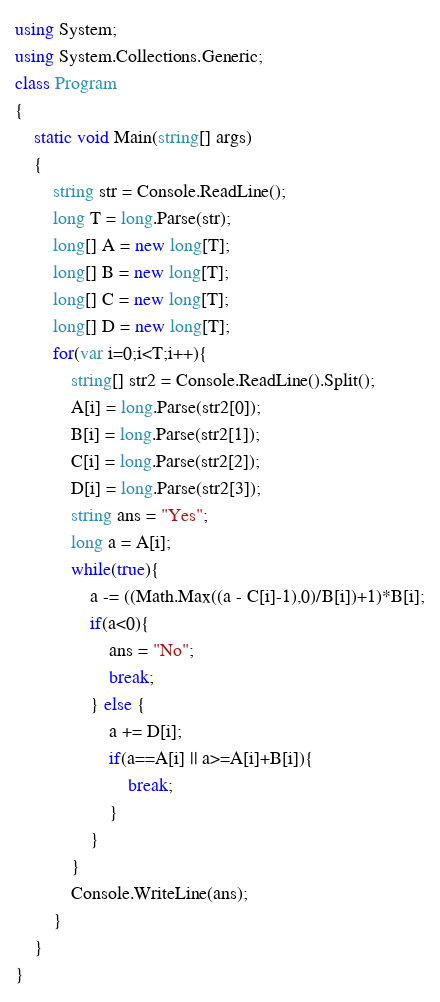Convert code to text. <code><loc_0><loc_0><loc_500><loc_500><_C#_>using System;
using System.Collections.Generic;
class Program
{
	static void Main(string[] args)
	{
		string str = Console.ReadLine();
		long T = long.Parse(str);
		long[] A = new long[T];
		long[] B = new long[T];
		long[] C = new long[T];
		long[] D = new long[T];
		for(var i=0;i<T;i++){
			string[] str2 = Console.ReadLine().Split();
			A[i] = long.Parse(str2[0]);
			B[i] = long.Parse(str2[1]);
			C[i] = long.Parse(str2[2]);
			D[i] = long.Parse(str2[3]);
			string ans = "Yes";
			long a = A[i];
			while(true){
				a -= ((Math.Max((a - C[i]-1),0)/B[i])+1)*B[i];
				if(a<0){
					ans = "No";
					break;
				} else {
					a += D[i];
					if(a==A[i] || a>=A[i]+B[i]){
						break;
					}
				}
			}
			Console.WriteLine(ans);
		}
	}
}</code> 